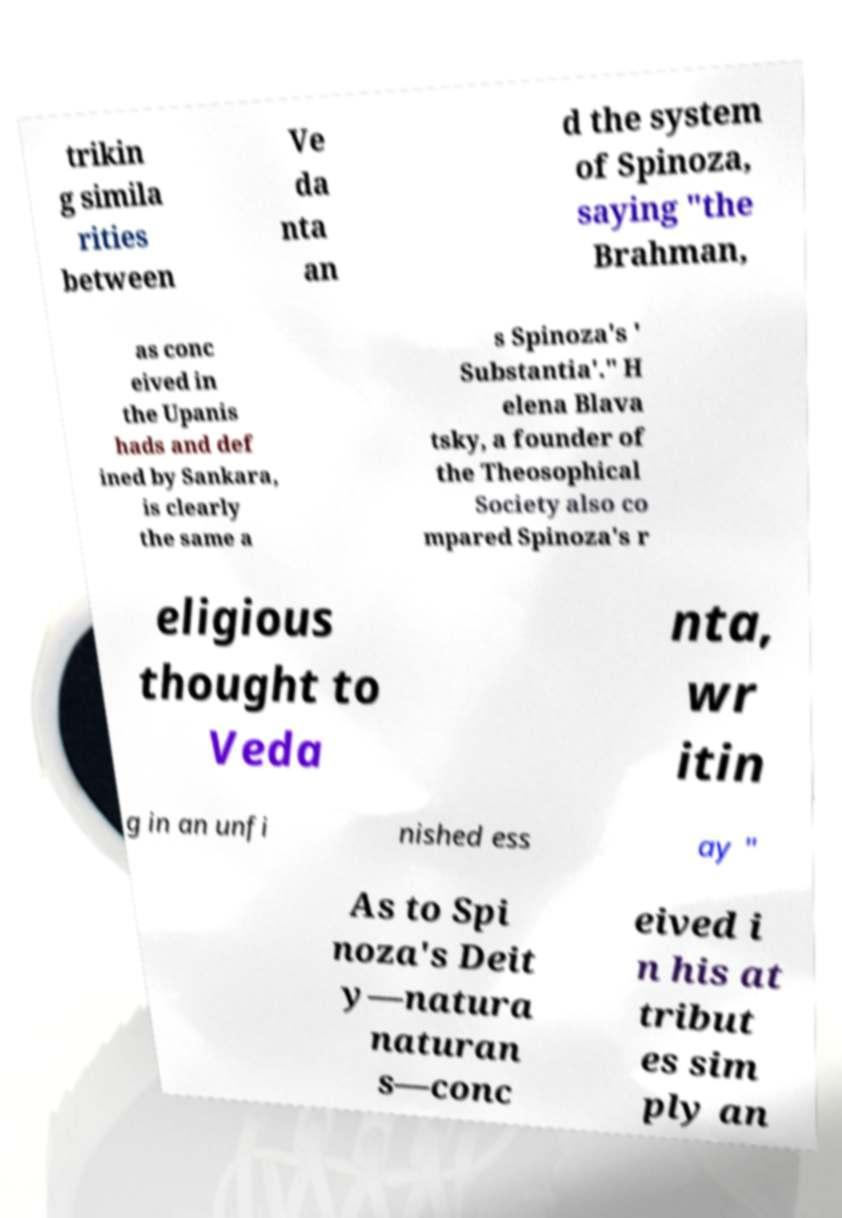Please identify and transcribe the text found in this image. trikin g simila rities between Ve da nta an d the system of Spinoza, saying "the Brahman, as conc eived in the Upanis hads and def ined by Sankara, is clearly the same a s Spinoza's ' Substantia'." H elena Blava tsky, a founder of the Theosophical Society also co mpared Spinoza's r eligious thought to Veda nta, wr itin g in an unfi nished ess ay " As to Spi noza's Deit y—natura naturan s—conc eived i n his at tribut es sim ply an 